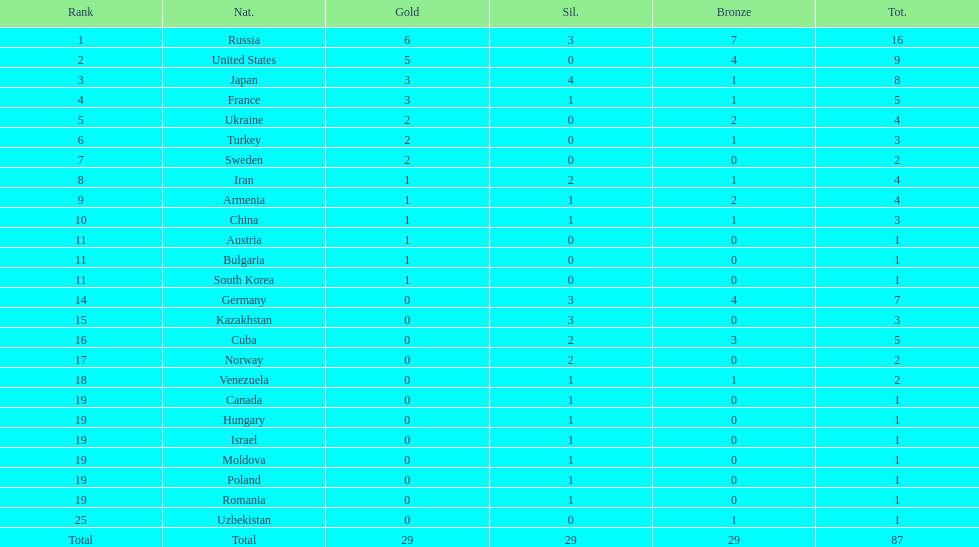Would you be able to parse every entry in this table? {'header': ['Rank', 'Nat.', 'Gold', 'Sil.', 'Bronze', 'Tot.'], 'rows': [['1', 'Russia', '6', '3', '7', '16'], ['2', 'United States', '5', '0', '4', '9'], ['3', 'Japan', '3', '4', '1', '8'], ['4', 'France', '3', '1', '1', '5'], ['5', 'Ukraine', '2', '0', '2', '4'], ['6', 'Turkey', '2', '0', '1', '3'], ['7', 'Sweden', '2', '0', '0', '2'], ['8', 'Iran', '1', '2', '1', '4'], ['9', 'Armenia', '1', '1', '2', '4'], ['10', 'China', '1', '1', '1', '3'], ['11', 'Austria', '1', '0', '0', '1'], ['11', 'Bulgaria', '1', '0', '0', '1'], ['11', 'South Korea', '1', '0', '0', '1'], ['14', 'Germany', '0', '3', '4', '7'], ['15', 'Kazakhstan', '0', '3', '0', '3'], ['16', 'Cuba', '0', '2', '3', '5'], ['17', 'Norway', '0', '2', '0', '2'], ['18', 'Venezuela', '0', '1', '1', '2'], ['19', 'Canada', '0', '1', '0', '1'], ['19', 'Hungary', '0', '1', '0', '1'], ['19', 'Israel', '0', '1', '0', '1'], ['19', 'Moldova', '0', '1', '0', '1'], ['19', 'Poland', '0', '1', '0', '1'], ['19', 'Romania', '0', '1', '0', '1'], ['25', 'Uzbekistan', '0', '0', '1', '1'], ['Total', 'Total', '29', '29', '29', '87']]} Japan and france each won how many gold medals? 3. 